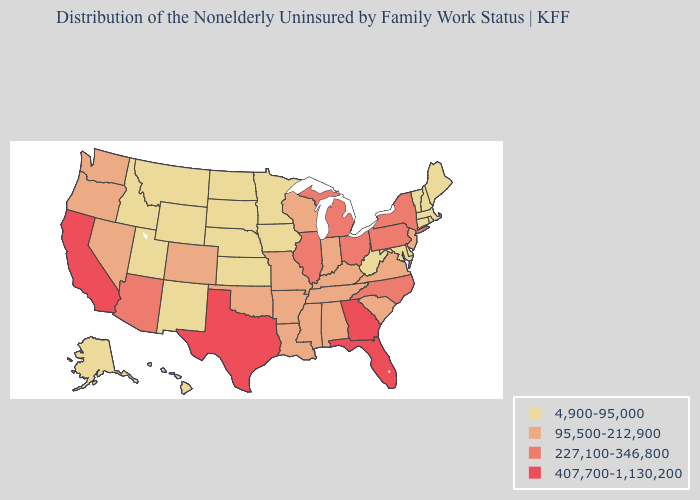Among the states that border Tennessee , which have the highest value?
Short answer required. Georgia. What is the value of Montana?
Answer briefly. 4,900-95,000. Among the states that border Connecticut , does Massachusetts have the highest value?
Quick response, please. No. Does the map have missing data?
Be succinct. No. Name the states that have a value in the range 4,900-95,000?
Give a very brief answer. Alaska, Connecticut, Delaware, Hawaii, Idaho, Iowa, Kansas, Maine, Maryland, Massachusetts, Minnesota, Montana, Nebraska, New Hampshire, New Mexico, North Dakota, Rhode Island, South Dakota, Utah, Vermont, West Virginia, Wyoming. What is the highest value in states that border Tennessee?
Concise answer only. 407,700-1,130,200. Name the states that have a value in the range 407,700-1,130,200?
Short answer required. California, Florida, Georgia, Texas. Does the map have missing data?
Keep it brief. No. Name the states that have a value in the range 95,500-212,900?
Be succinct. Alabama, Arkansas, Colorado, Indiana, Kentucky, Louisiana, Mississippi, Missouri, Nevada, New Jersey, Oklahoma, Oregon, South Carolina, Tennessee, Virginia, Washington, Wisconsin. What is the value of Utah?
Concise answer only. 4,900-95,000. Which states have the lowest value in the USA?
Keep it brief. Alaska, Connecticut, Delaware, Hawaii, Idaho, Iowa, Kansas, Maine, Maryland, Massachusetts, Minnesota, Montana, Nebraska, New Hampshire, New Mexico, North Dakota, Rhode Island, South Dakota, Utah, Vermont, West Virginia, Wyoming. What is the lowest value in states that border Arizona?
Be succinct. 4,900-95,000. Name the states that have a value in the range 4,900-95,000?
Write a very short answer. Alaska, Connecticut, Delaware, Hawaii, Idaho, Iowa, Kansas, Maine, Maryland, Massachusetts, Minnesota, Montana, Nebraska, New Hampshire, New Mexico, North Dakota, Rhode Island, South Dakota, Utah, Vermont, West Virginia, Wyoming. Name the states that have a value in the range 4,900-95,000?
Short answer required. Alaska, Connecticut, Delaware, Hawaii, Idaho, Iowa, Kansas, Maine, Maryland, Massachusetts, Minnesota, Montana, Nebraska, New Hampshire, New Mexico, North Dakota, Rhode Island, South Dakota, Utah, Vermont, West Virginia, Wyoming. What is the value of Mississippi?
Write a very short answer. 95,500-212,900. 